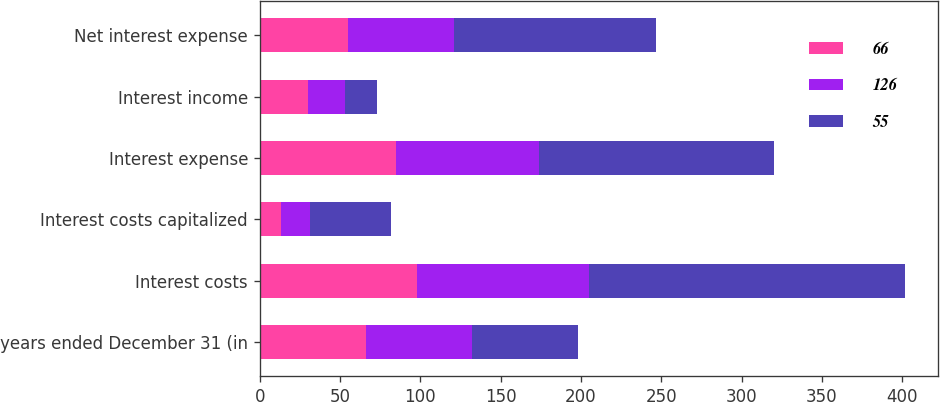Convert chart. <chart><loc_0><loc_0><loc_500><loc_500><stacked_bar_chart><ecel><fcel>years ended December 31 (in<fcel>Interest costs<fcel>Interest costs capitalized<fcel>Interest expense<fcel>Interest income<fcel>Net interest expense<nl><fcel>66<fcel>66<fcel>98<fcel>13<fcel>85<fcel>30<fcel>55<nl><fcel>126<fcel>66<fcel>107<fcel>18<fcel>89<fcel>23<fcel>66<nl><fcel>55<fcel>66<fcel>197<fcel>51<fcel>146<fcel>20<fcel>126<nl></chart> 